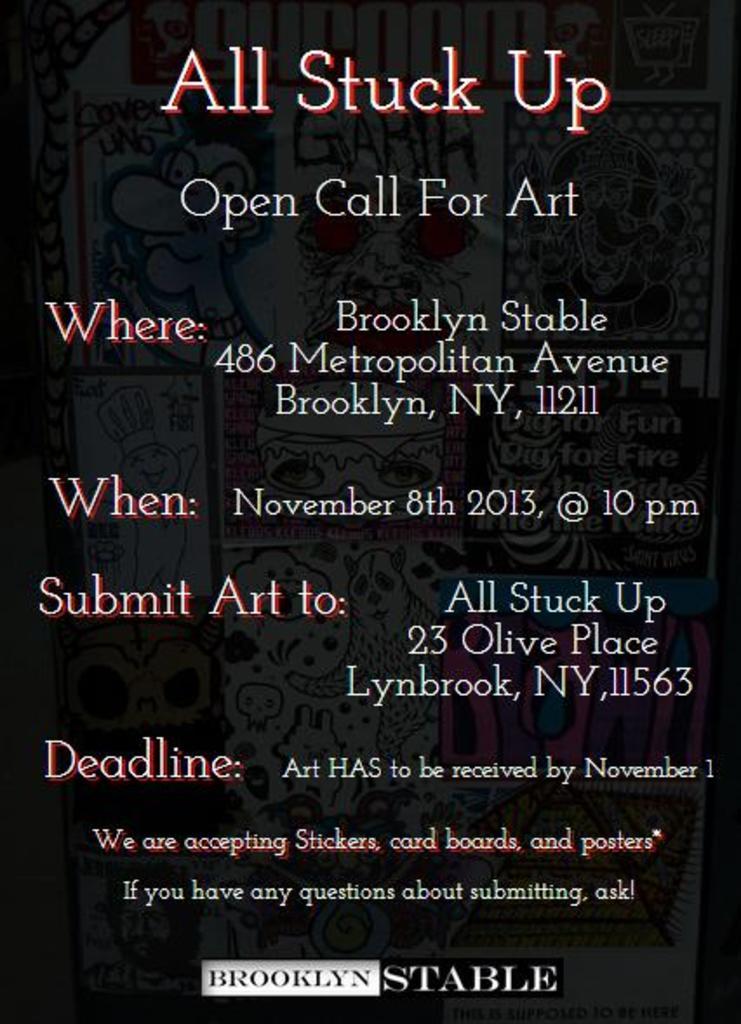When is the deadline that art must be received by?
Make the answer very short. November 1. 